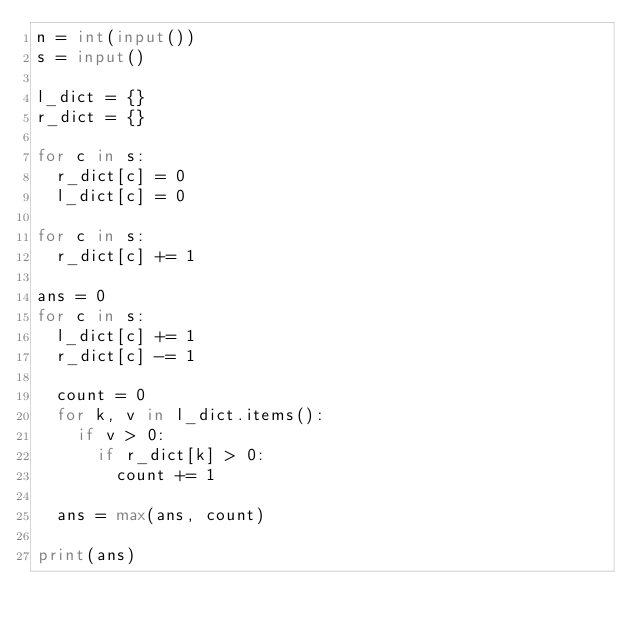<code> <loc_0><loc_0><loc_500><loc_500><_Python_>n = int(input())
s = input()

l_dict = {}
r_dict = {}

for c in s:
	r_dict[c] = 0
	l_dict[c] = 0

for c in s:
	r_dict[c] += 1

ans = 0
for c in s:
	l_dict[c] += 1
	r_dict[c] -= 1

	count = 0
	for k, v in l_dict.items():
		if v > 0:
			if r_dict[k] > 0:
				count += 1

	ans = max(ans, count)

print(ans)
	</code> 